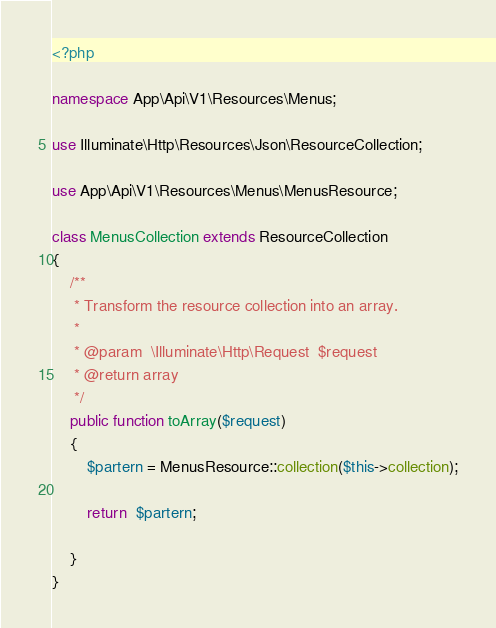Convert code to text. <code><loc_0><loc_0><loc_500><loc_500><_PHP_><?php

namespace App\Api\V1\Resources\Menus;

use Illuminate\Http\Resources\Json\ResourceCollection;

use App\Api\V1\Resources\Menus\MenusResource;

class MenusCollection extends ResourceCollection
{
    /**
     * Transform the resource collection into an array.
     *
     * @param  \Illuminate\Http\Request  $request
     * @return array
     */
    public function toArray($request)
    {
        $partern = MenusResource::collection($this->collection);
        
        return  $partern;
       
    }
}
</code> 